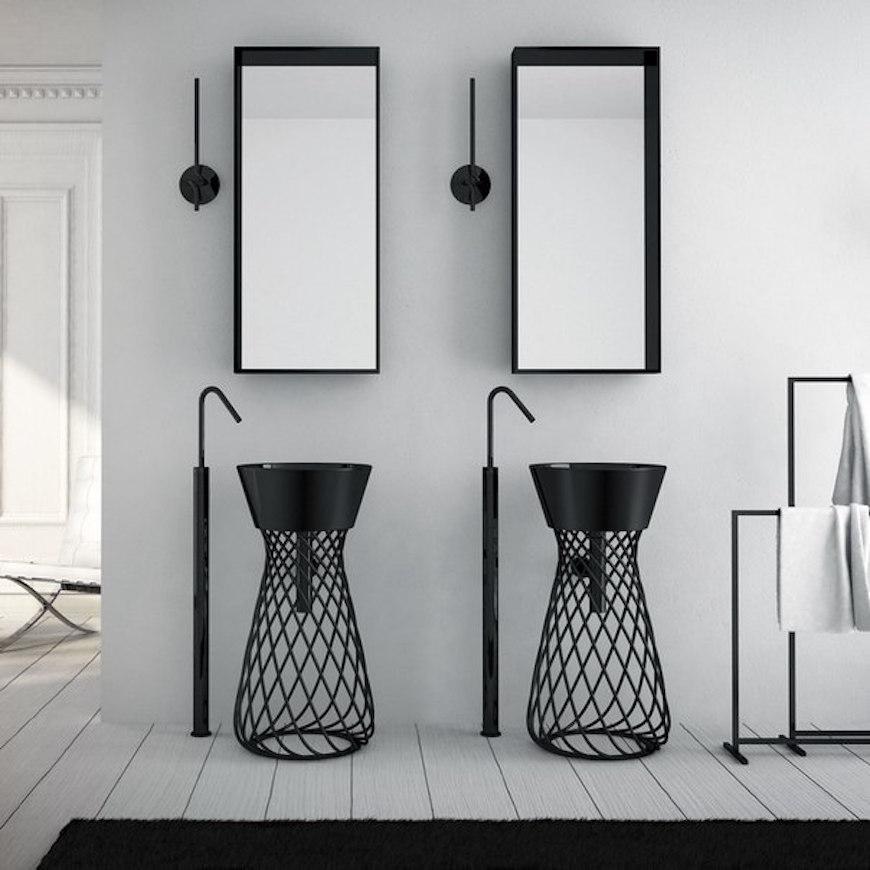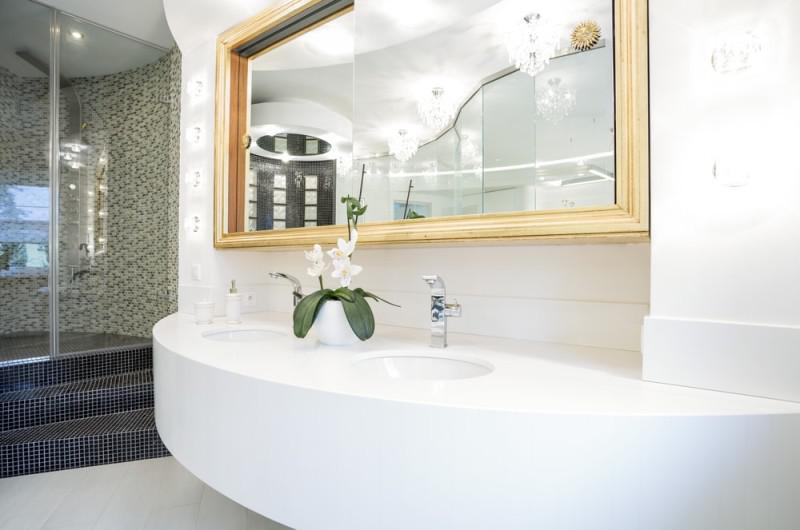The first image is the image on the left, the second image is the image on the right. Given the left and right images, does the statement "The sink in the right image is a bowl sitting on a counter." hold true? Answer yes or no. No. The first image is the image on the left, the second image is the image on the right. Assess this claim about the two images: "Both images in the pair show sinks and one of them is seashell themed.". Correct or not? Answer yes or no. No. 